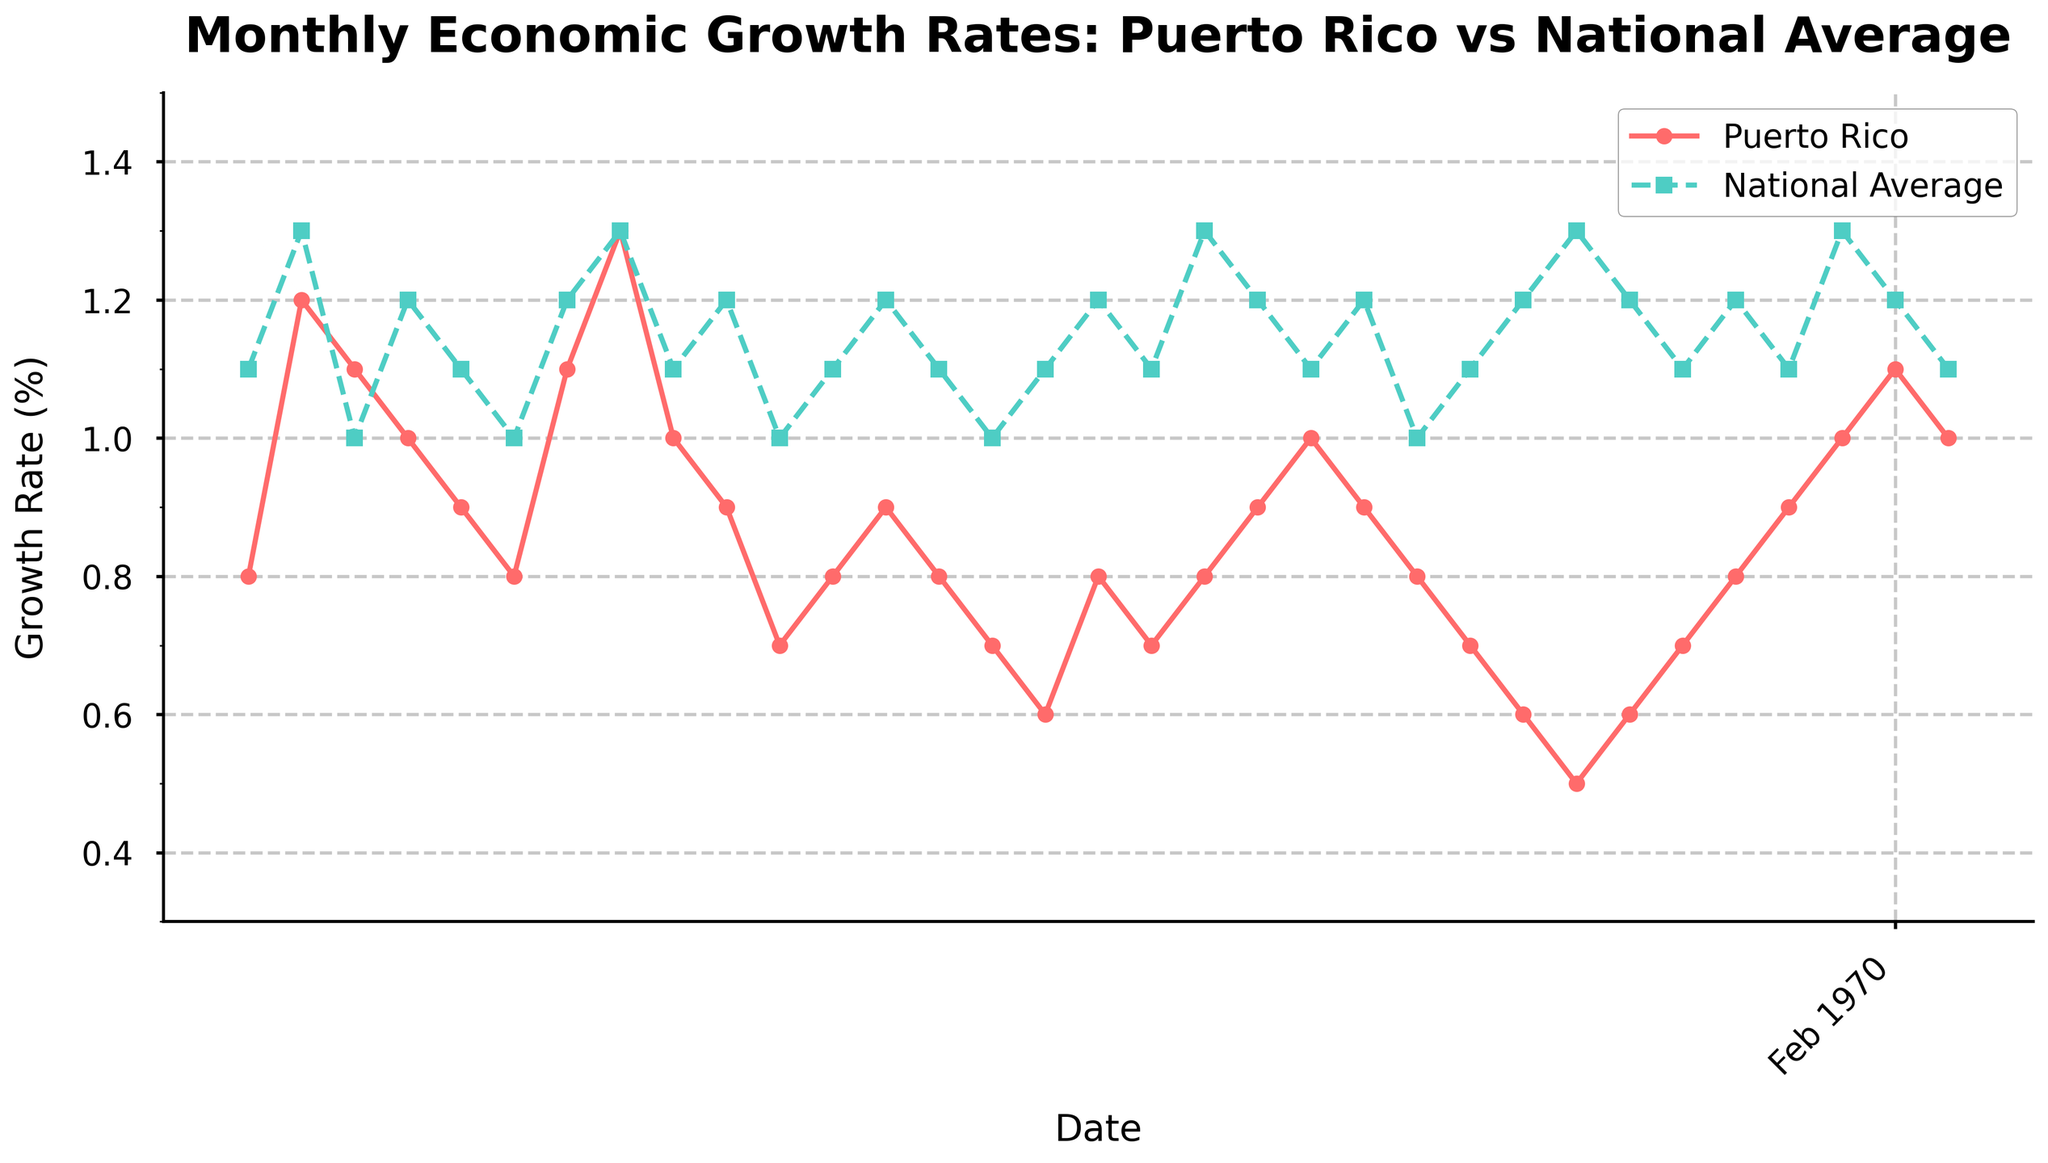What is the title of the plot? The title is located at the top of the figure and typically summarizes what the plot is about. According to the provided code, the title is "Monthly Economic Growth Rates: Puerto Rico vs National Average".
Answer: Monthly Economic Growth Rates: Puerto Rico vs National Average Which months show higher growth rates for Puerto Rico compared to the national average? To determine this, look at the points where the Puerto Rico line (red circles) is above the national average line (teal squares).
Answer: March 2021, September 2021, August 2023, and September 2023 What is the range of the y-axis on the plot? The range of the y-axis is set within the code using set_ylim(0.3, 1.5), meaning it shows values from 0.3% to 1.5%. This range can be confirmed by looking at the y-axis of the plot.
Answer: 0.3% to 1.5% What is the difference in growth rates between Puerto Rico and the national average in July 2021? Look at the values for Puerto Rico and the national average in July 2021. Puerto Rico has a growth rate of 1.1% and the national average is 1.2%. Subtract the national average from Puerto Rico's growth rate: 1.1 - 1.2 = -0.1.
Answer: -0.1% During which month was the economic growth rate the lowest for Puerto Rico? Scan through the values represented by the red circles on the plot and find the lowest point, which corresponds to February 2023 with a growth rate of 0.5%.
Answer: February 2023 On average, how did Puerto Rico's economic growth rate compare to the national average over the entire period? First, calculate the average growth rate for Puerto Rico and the national average separately, then compare them. Puerto Rico has an average growth rate of approximately 0.85%, while the national average is around 1.13%. This shows that Puerto Rico's growth rate is generally lower.
Answer: Lower Which months displayed identical growth rates for both Puerto Rico and the national average? Look for points in the plot where the red circles and teal squares align precisely. These occur in February 2021 and August 2021 with growth rates of 1.2% and March 2023 at 1.1%.
Answer: February 2021, August 2021, March 2023 What trend can be observed in Puerto Rico's economic growth rates from January 2023 to September 2023? Observe the red line with circles for the period between January 2023 and September 2023. From January onwards, it initially drops, then gradually rises, indicating an overall upward trend towards September.
Answer: Upward trend 